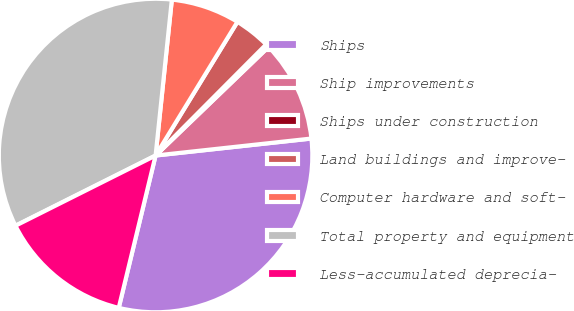Convert chart. <chart><loc_0><loc_0><loc_500><loc_500><pie_chart><fcel>Ships<fcel>Ship improvements<fcel>Ships under construction<fcel>Land buildings and improve-<fcel>Computer hardware and soft-<fcel>Total property and equipment<fcel>Less-accumulated deprecia-<nl><fcel>30.51%<fcel>10.46%<fcel>0.35%<fcel>3.72%<fcel>7.09%<fcel>34.05%<fcel>13.83%<nl></chart> 